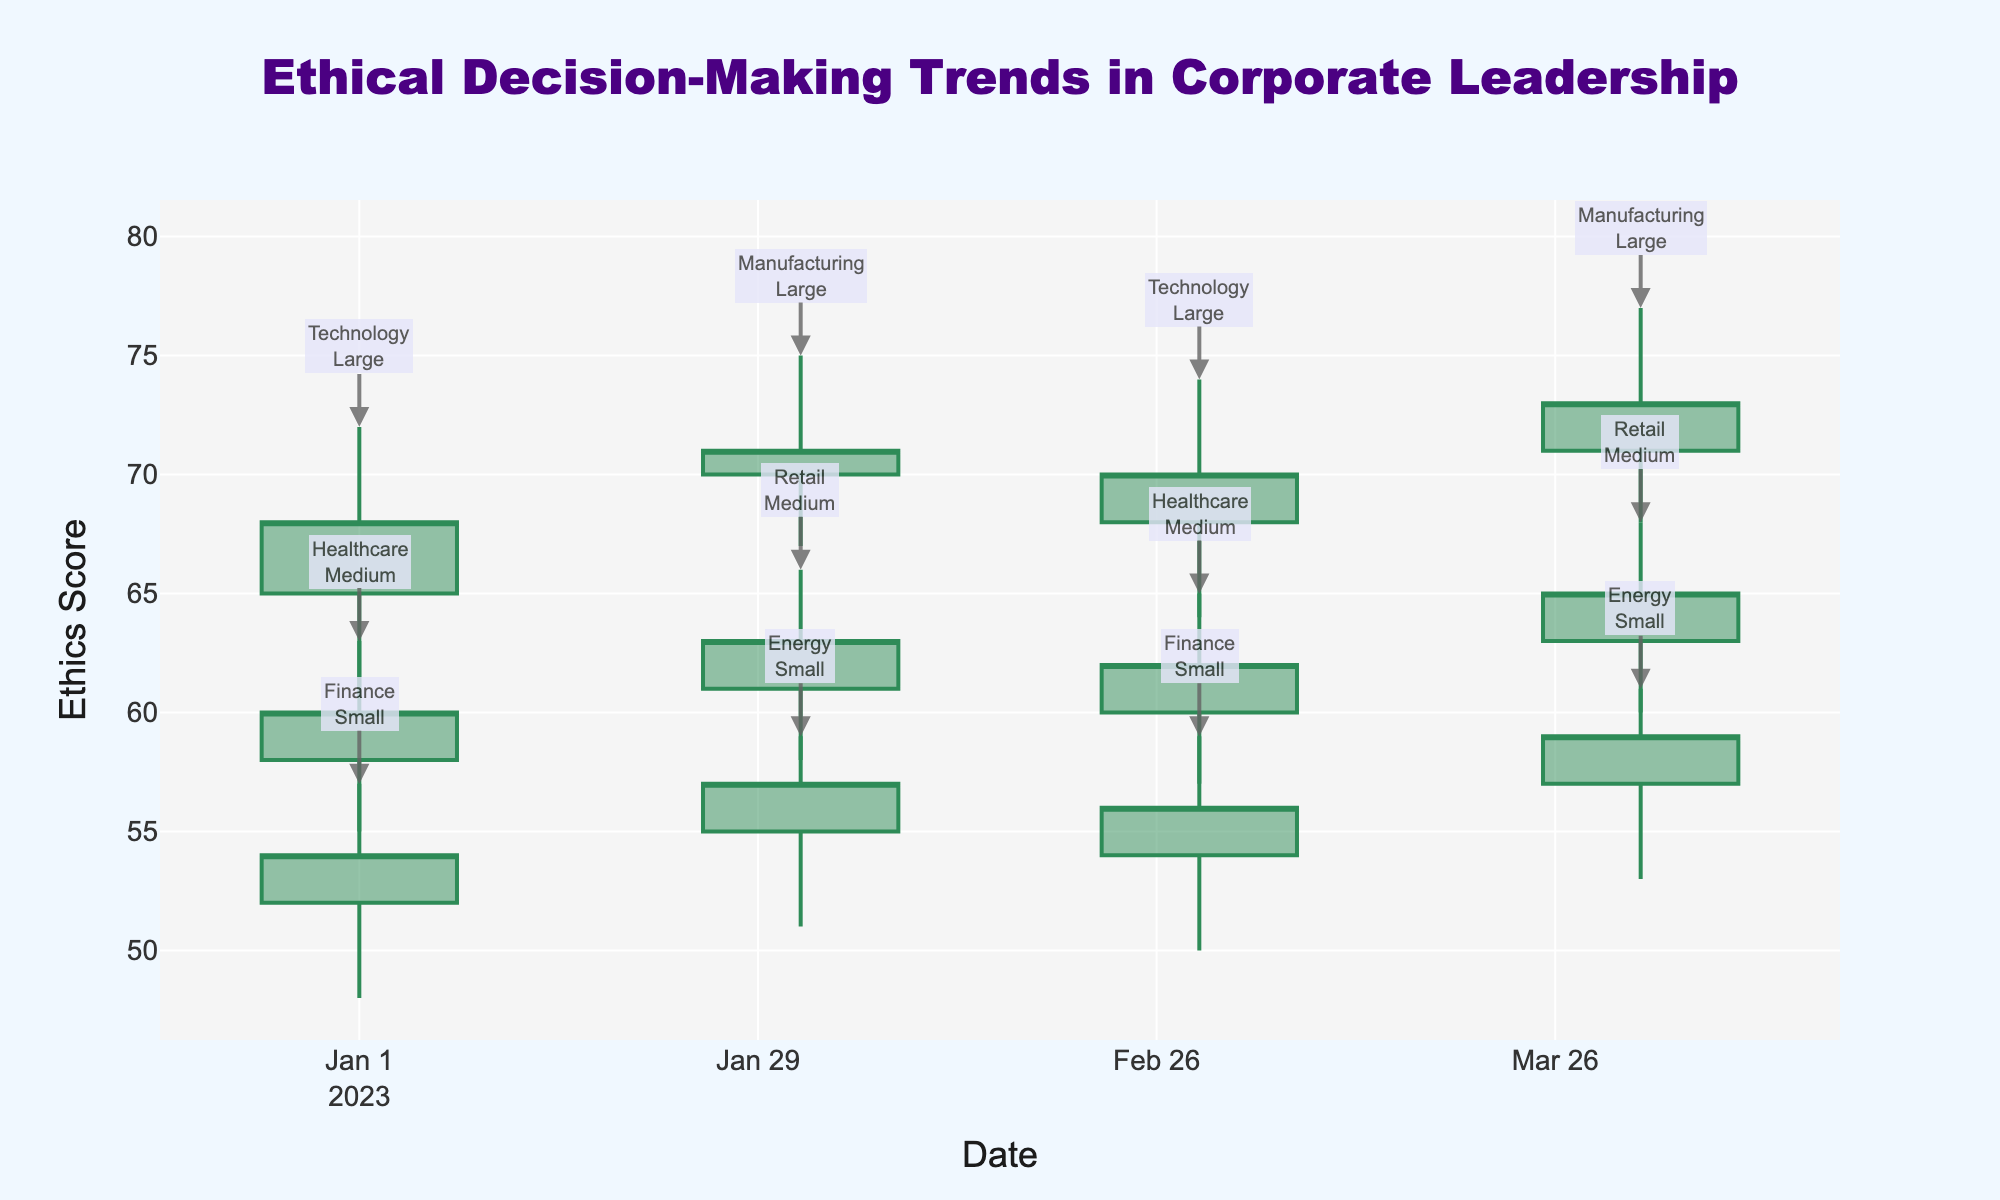What is the title of the chart? The title of the chart is displayed at the top center and reads "Ethical Decision-Making Trends in Corporate Leadership."
Answer: Ethical Decision-Making Trends in Corporate Leadership Which axis represents time in this chart? The x-axis at the bottom of the chart represents time, as indicated by the "Date" label.
Answer: x-axis What is the color of the increasing line in the OHLC chart? The increasing line in the OHLC chart is colored Sea Green.
Answer: Sea Green How many different industries are represented in this chart? The industries are labeled near the high points of the data points; counting them yields five industries: Technology, Healthcare, Finance, Manufacturing, Retail, and Energy.
Answer: Six What company size has the highest closing value on March 1, 2023? Looking at March 1, 2023, and observing the closing values, Technology (Large) has the highest closing value of 70.
Answer: Large What is the difference between the highest value in the Technology industry in January 2023 and March 2023? The highest value in Technology in January 2023 is 72, and in March 2023 is 74. The difference is 74 - 72 = 2.
Answer: 2 Is the closing value for Finance in April 2023 higher than its value in March 2023? The closing value for Finance in April 2023 is missing, but comparing available data, the closing value is 56 in March 2023.
Answer: No value for comparison Which industry has the highest volume of fluctuations in April 2023, and what is the range of these fluctuations? April 2023 Manufacturing shows the highest fluctuations with ranges between 77 (high) and 68 (low). The range is 77 - 68 = 9.
Answer: Manufacturing, 9 What is the median closing value for all industries in January 2023? The closing values for January 2023 across industries are 68, 60, and 54. The median value is the middle value when they are ordered: 54, 60, 68. The median is 60.
Answer: 60 